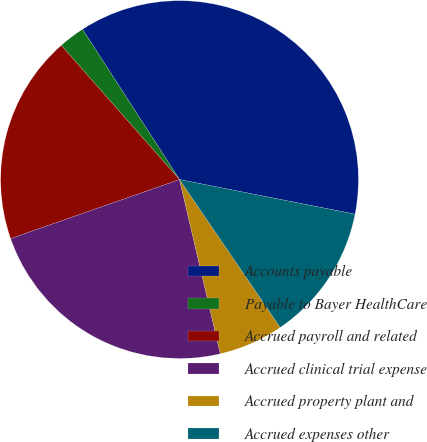<chart> <loc_0><loc_0><loc_500><loc_500><pie_chart><fcel>Accounts payable<fcel>Payable to Bayer HealthCare<fcel>Accrued payroll and related<fcel>Accrued clinical trial expense<fcel>Accrued property plant and<fcel>Accrued expenses other<nl><fcel>37.22%<fcel>2.37%<fcel>18.86%<fcel>23.31%<fcel>5.85%<fcel>12.39%<nl></chart> 